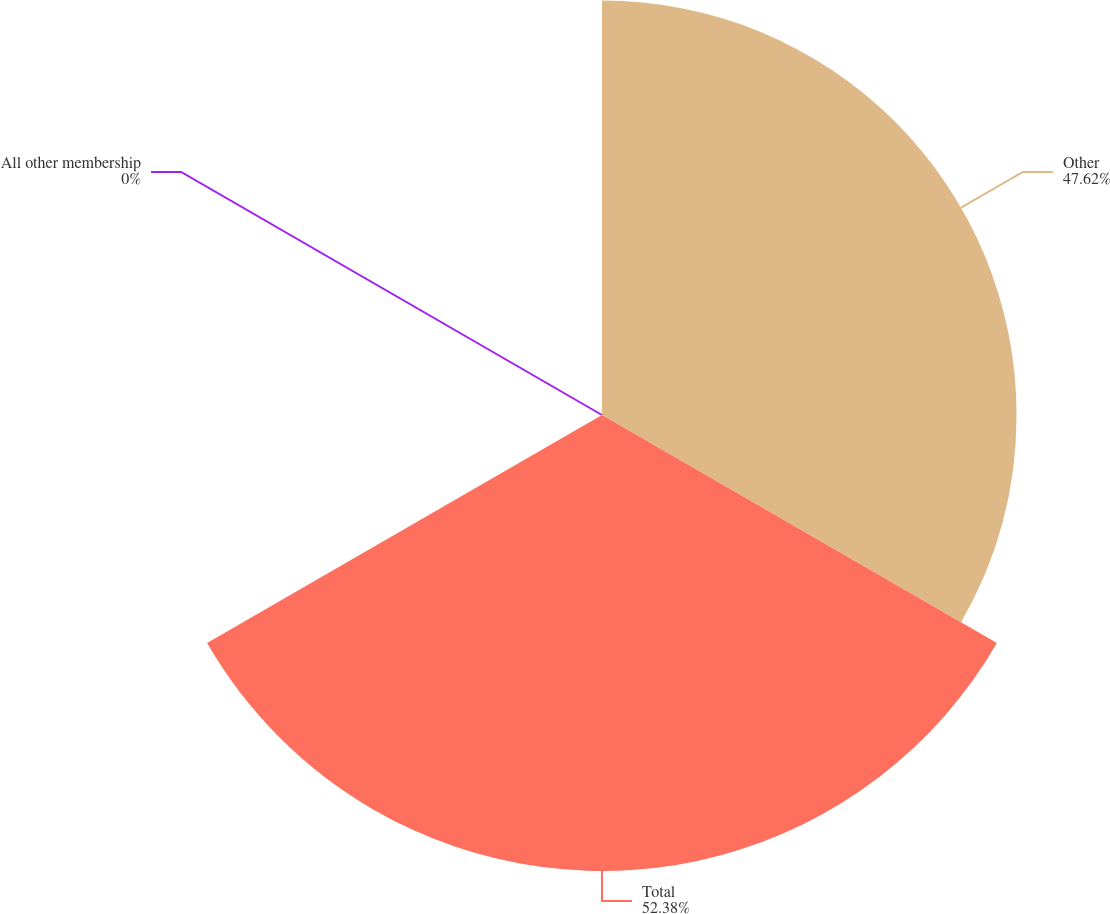Convert chart. <chart><loc_0><loc_0><loc_500><loc_500><pie_chart><fcel>Other<fcel>Total<fcel>All other membership<nl><fcel>47.62%<fcel>52.38%<fcel>0.0%<nl></chart> 